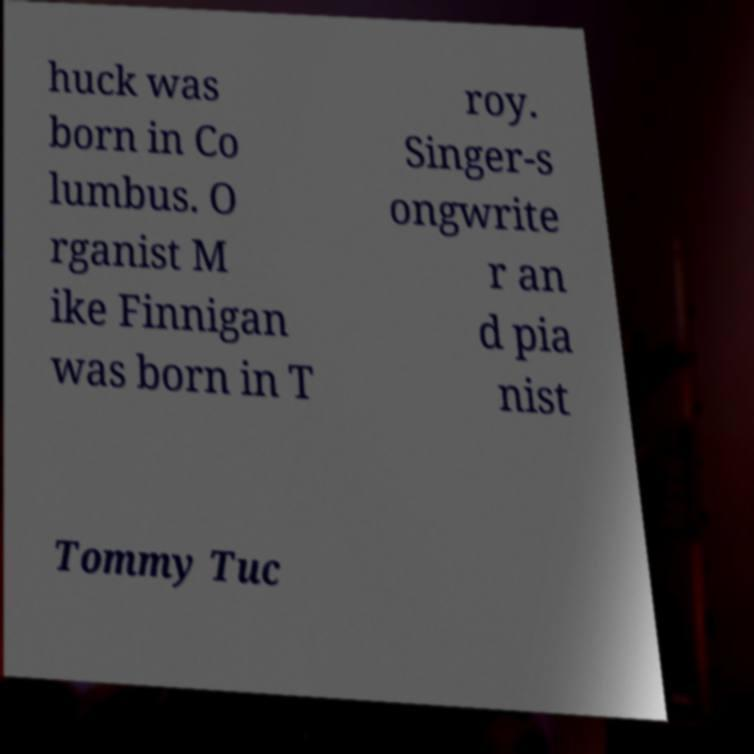I need the written content from this picture converted into text. Can you do that? huck was born in Co lumbus. O rganist M ike Finnigan was born in T roy. Singer-s ongwrite r an d pia nist Tommy Tuc 